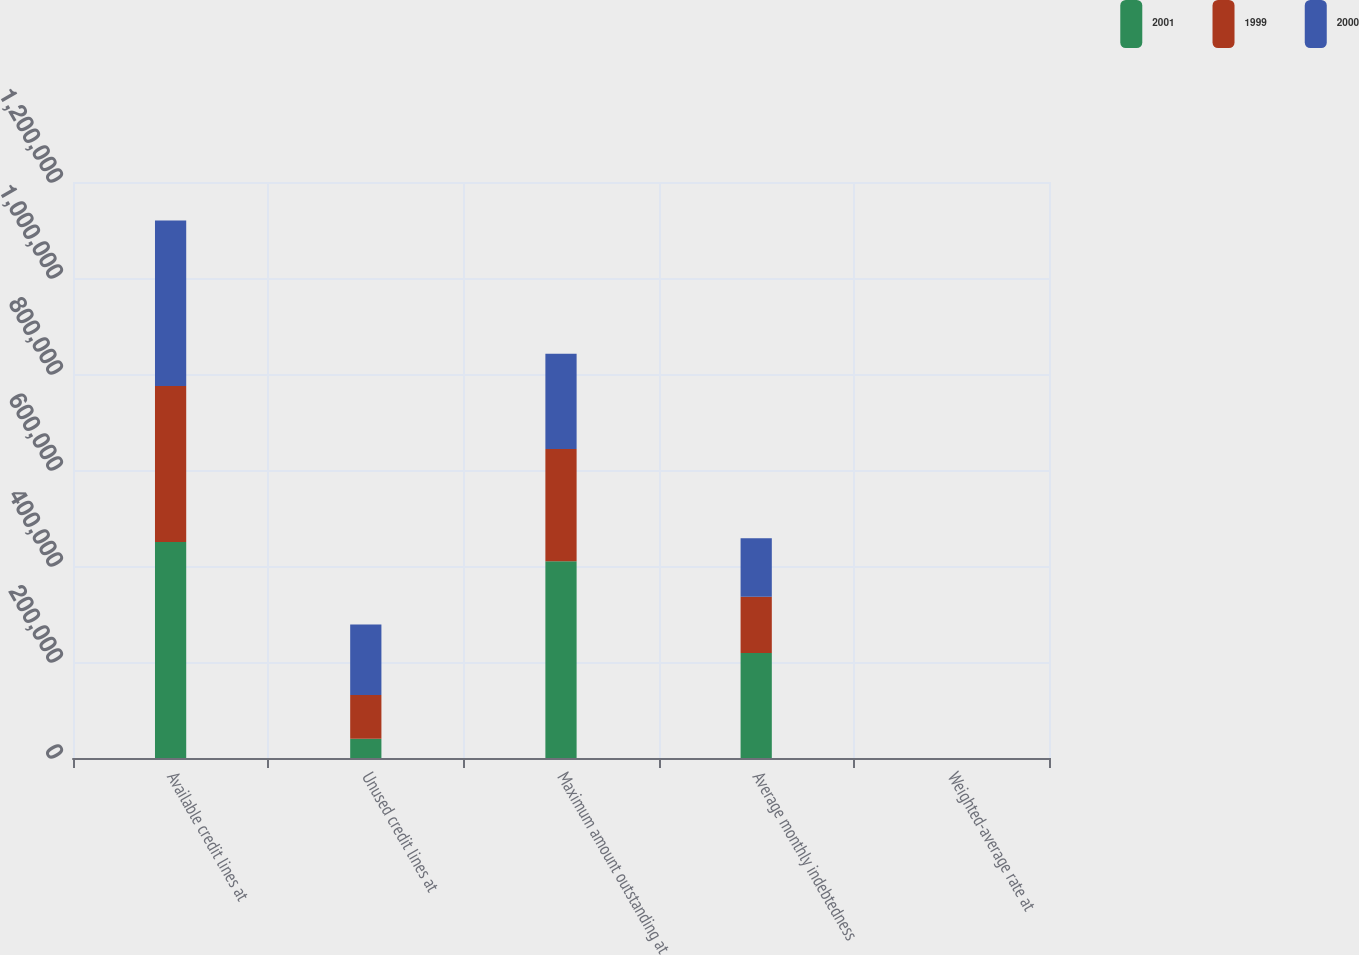Convert chart. <chart><loc_0><loc_0><loc_500><loc_500><stacked_bar_chart><ecel><fcel>Available credit lines at<fcel>Unused credit lines at<fcel>Maximum amount outstanding at<fcel>Average monthly indebtedness<fcel>Weighted-average rate at<nl><fcel>2001<fcel>450000<fcel>40000<fcel>410000<fcel>219000<fcel>2.35<nl><fcel>1999<fcel>325000<fcel>91000<fcel>234000<fcel>117000<fcel>7.31<nl><fcel>2000<fcel>345000<fcel>147000<fcel>198000<fcel>122000<fcel>7.11<nl></chart> 